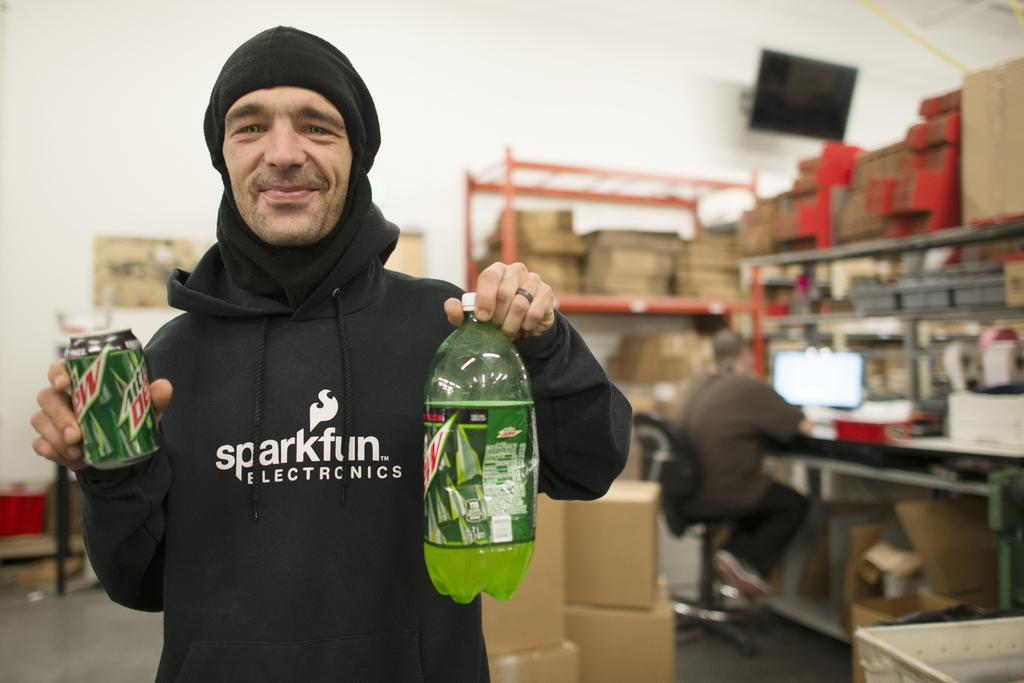What objects is the person holding in the image? The person is holding a bottle and a tin. What can be seen in the background of the image? There are racks in the background, and they are filled with cardboard. What is the person sitting on in the image? The man is sitting on a chair. What is the person doing while sitting on the chair? The man is working in front of a monitor. Where can you find the best deals for these items? The image does not provide information about where to find the best deals. --- Facts: 1. There is a person in the image. 2. The person is wearing a hat. 3. The person is holding a book. 4. The person is standing near a bookshelf. 5. The bookshelf is filled with books. Absurd Topics: elephant, piano, sunflower Conversation: Who or what is in the image? There is a person in the image. What is the person wearing in the image? The person is wearing a hat. What is the person holding in the image? The person is holding a book. Where is the person standing in the image? The person is standing near a bookshelf. What can be seen on the bookshelf in the image? The bookshelf is filled with books. Reasoning: Let's think step by step in order to produce the conversation. We start by identifying the main subject of the image, which is the person. Next, we describe specific features of the person, such as the hat they are wearing. Then, we observe the actions of the person, noting that they are holding a book. Finally, we describe the setting where the person is located, which includes the bookshelf filled with books. Absurd Question/Answer: Can you hear the piano being played by the sunflower in the image? There is no piano or sunflower present in the image. 